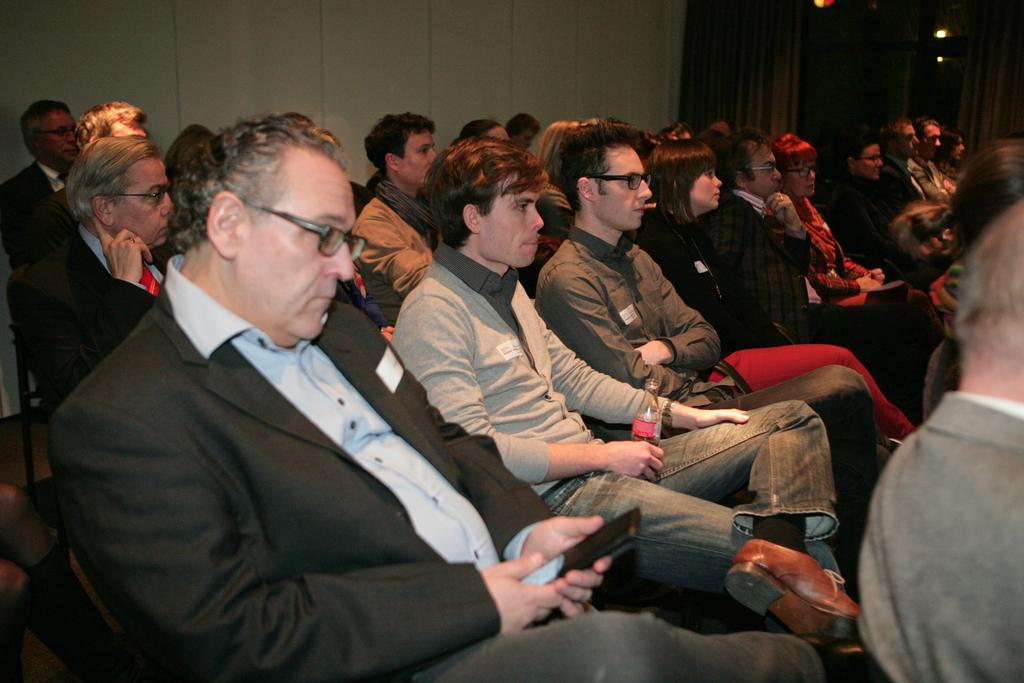How many people are in the image? There are people in the image, but the exact number is not specified. What are some of the people doing in the image? Some of the people are sitting in the image. Are any of the people holding objects in the image? Yes, some of the people are holding things in the image. What type of shoe can be seen in the scene with the deer? There is no shoe, scene, or deer present in the image. 